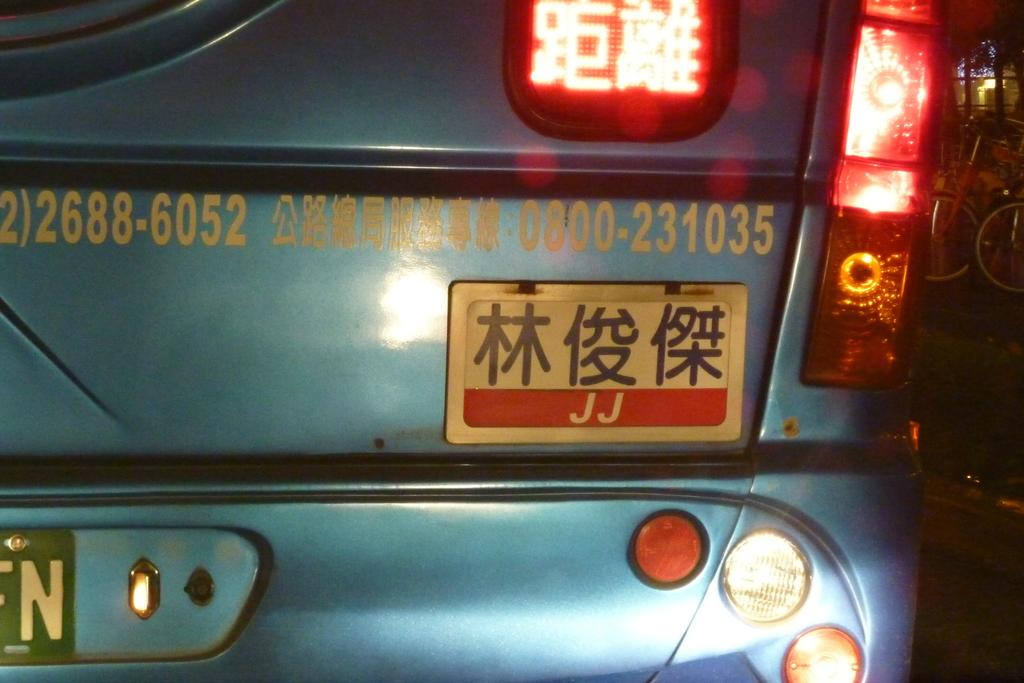What color is the car in the image? The car in the image is blue. What part of the car is the focus of the image? The image shows a close view of the car's trunk. What other car features are visible in the image? The car's tail lights are visible in the image. What else can be seen in the image besides the car? There are parked cycles in the right corner of the image. What type of gun can be seen in the image? There is no gun present in the image; it features a blue car with a close view of the trunk and parked cycles in the right corner. 